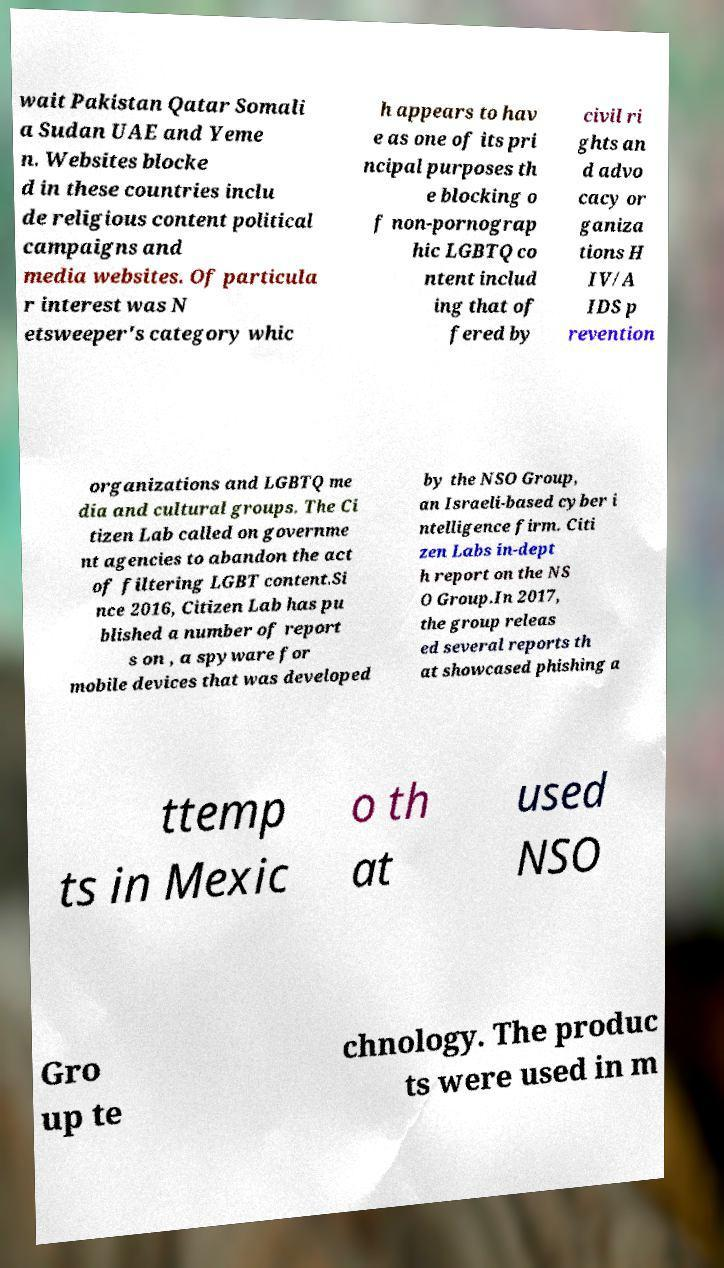What messages or text are displayed in this image? I need them in a readable, typed format. wait Pakistan Qatar Somali a Sudan UAE and Yeme n. Websites blocke d in these countries inclu de religious content political campaigns and media websites. Of particula r interest was N etsweeper's category whic h appears to hav e as one of its pri ncipal purposes th e blocking o f non-pornograp hic LGBTQ co ntent includ ing that of fered by civil ri ghts an d advo cacy or ganiza tions H IV/A IDS p revention organizations and LGBTQ me dia and cultural groups. The Ci tizen Lab called on governme nt agencies to abandon the act of filtering LGBT content.Si nce 2016, Citizen Lab has pu blished a number of report s on , a spyware for mobile devices that was developed by the NSO Group, an Israeli-based cyber i ntelligence firm. Citi zen Labs in-dept h report on the NS O Group.In 2017, the group releas ed several reports th at showcased phishing a ttemp ts in Mexic o th at used NSO Gro up te chnology. The produc ts were used in m 